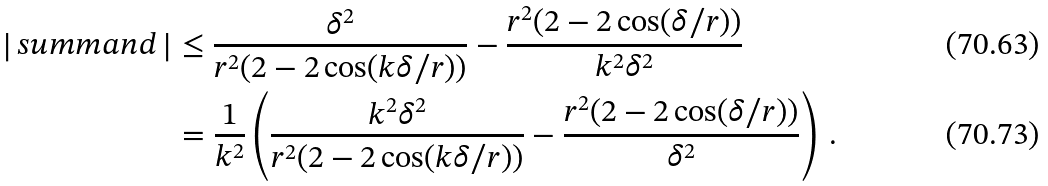Convert formula to latex. <formula><loc_0><loc_0><loc_500><loc_500>\left | \, s u m m a n d \, \right | & \leq \frac { \delta ^ { 2 } } { r ^ { 2 } ( 2 - 2 \cos ( k \delta / r ) ) } - \frac { r ^ { 2 } ( 2 - 2 \cos ( \delta / r ) ) } { k ^ { 2 } \delta ^ { 2 } } \\ & = \frac { 1 } { k ^ { 2 } } \left ( \frac { k ^ { 2 } \delta ^ { 2 } } { r ^ { 2 } ( 2 - 2 \cos ( k \delta / r ) ) } - \frac { r ^ { 2 } ( 2 - 2 \cos ( \delta / r ) ) } { \delta ^ { 2 } } \right ) \, .</formula> 